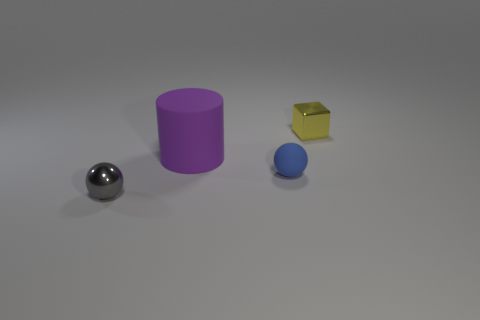Is there anything else that has the same size as the purple rubber cylinder?
Ensure brevity in your answer.  No. There is a blue object that is made of the same material as the large purple cylinder; what is its shape?
Offer a very short reply. Sphere. Are there fewer gray metal balls than tiny objects?
Offer a terse response. Yes. Is the material of the blue sphere the same as the tiny gray sphere?
Your answer should be very brief. No. What number of other things are the same color as the small cube?
Keep it short and to the point. 0. Are there more tiny things than things?
Your answer should be very brief. No. There is a blue ball; is it the same size as the metal thing that is in front of the shiny block?
Your answer should be very brief. Yes. What color is the shiny object that is behind the small gray object?
Your answer should be compact. Yellow. How many brown things are either tiny objects or large matte objects?
Ensure brevity in your answer.  0. The metal cube has what color?
Provide a short and direct response. Yellow. 